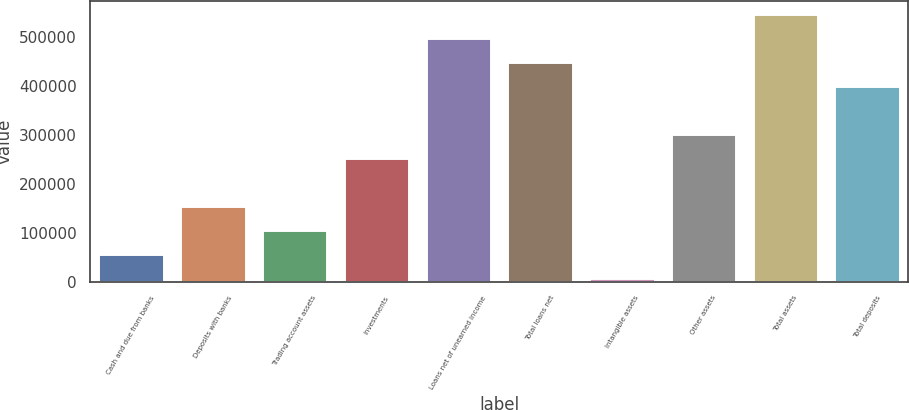Convert chart to OTSL. <chart><loc_0><loc_0><loc_500><loc_500><bar_chart><fcel>Cash and due from banks<fcel>Deposits with banks<fcel>Trading account assets<fcel>Investments<fcel>Loans net of unearned income<fcel>Total loans net<fcel>Intangible assets<fcel>Other assets<fcel>Total assets<fcel>Total deposits<nl><fcel>56031.8<fcel>153925<fcel>104979<fcel>251819<fcel>496553<fcel>447606<fcel>7085<fcel>300766<fcel>545500<fcel>398659<nl></chart> 